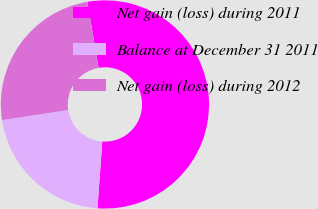<chart> <loc_0><loc_0><loc_500><loc_500><pie_chart><fcel>Net gain (loss) during 2011<fcel>Balance at December 31 2011<fcel>Net gain (loss) during 2012<nl><fcel>53.84%<fcel>21.46%<fcel>24.7%<nl></chart> 